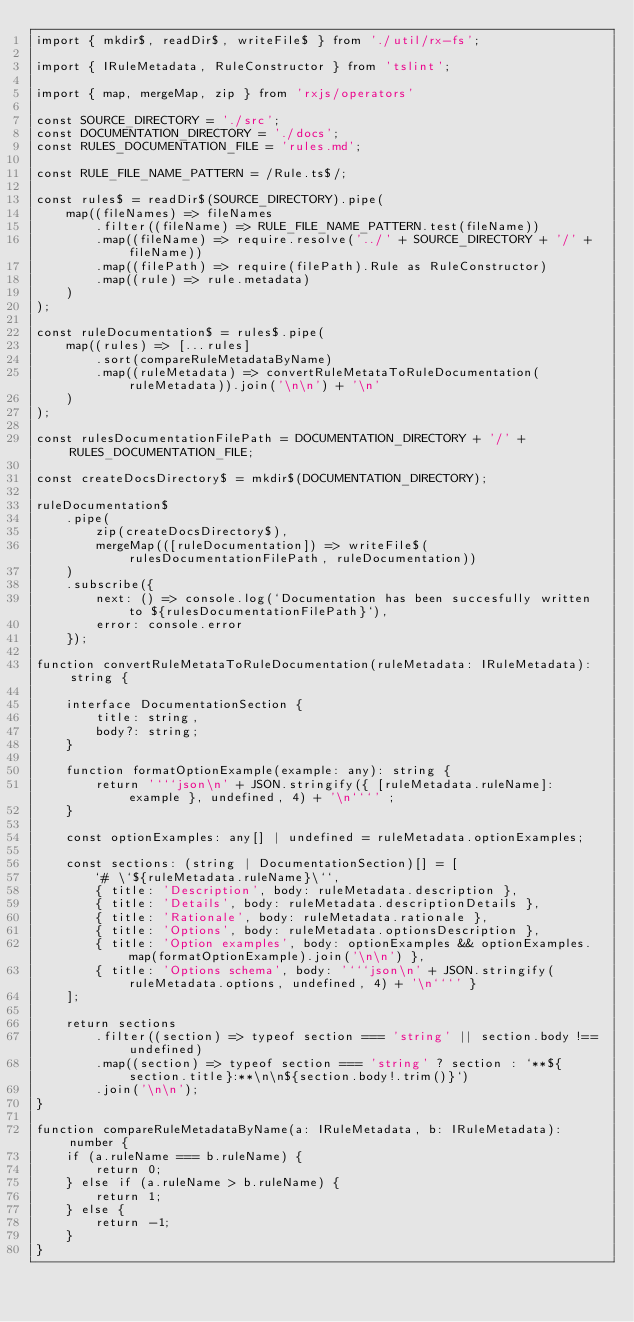Convert code to text. <code><loc_0><loc_0><loc_500><loc_500><_TypeScript_>import { mkdir$, readDir$, writeFile$ } from './util/rx-fs';

import { IRuleMetadata, RuleConstructor } from 'tslint';

import { map, mergeMap, zip } from 'rxjs/operators'

const SOURCE_DIRECTORY = './src';
const DOCUMENTATION_DIRECTORY = './docs';
const RULES_DOCUMENTATION_FILE = 'rules.md';

const RULE_FILE_NAME_PATTERN = /Rule.ts$/;

const rules$ = readDir$(SOURCE_DIRECTORY).pipe(
    map((fileNames) => fileNames
        .filter((fileName) => RULE_FILE_NAME_PATTERN.test(fileName))
        .map((fileName) => require.resolve('../' + SOURCE_DIRECTORY + '/' + fileName))
        .map((filePath) => require(filePath).Rule as RuleConstructor)
        .map((rule) => rule.metadata)
    )
);

const ruleDocumentation$ = rules$.pipe(
    map((rules) => [...rules]
        .sort(compareRuleMetadataByName)
        .map((ruleMetadata) => convertRuleMetataToRuleDocumentation(ruleMetadata)).join('\n\n') + '\n'
    )
);

const rulesDocumentationFilePath = DOCUMENTATION_DIRECTORY + '/' + RULES_DOCUMENTATION_FILE;

const createDocsDirectory$ = mkdir$(DOCUMENTATION_DIRECTORY);

ruleDocumentation$
    .pipe(
        zip(createDocsDirectory$),
        mergeMap(([ruleDocumentation]) => writeFile$(rulesDocumentationFilePath, ruleDocumentation))
    )
    .subscribe({
        next: () => console.log(`Documentation has been succesfully written to ${rulesDocumentationFilePath}`),
        error: console.error
    });

function convertRuleMetataToRuleDocumentation(ruleMetadata: IRuleMetadata): string {

    interface DocumentationSection {
        title: string,
        body?: string;
    }

    function formatOptionExample(example: any): string {
        return '```json\n' + JSON.stringify({ [ruleMetadata.ruleName]: example }, undefined, 4) + '\n```' ;
    }

    const optionExamples: any[] | undefined = ruleMetadata.optionExamples;

    const sections: (string | DocumentationSection)[] = [
        `# \`${ruleMetadata.ruleName}\``,
        { title: 'Description', body: ruleMetadata.description },
        { title: 'Details', body: ruleMetadata.descriptionDetails },
        { title: 'Rationale', body: ruleMetadata.rationale },
        { title: 'Options', body: ruleMetadata.optionsDescription },
        { title: 'Option examples', body: optionExamples && optionExamples.map(formatOptionExample).join('\n\n') },
        { title: 'Options schema', body: '```json\n' + JSON.stringify(ruleMetadata.options, undefined, 4) + '\n```' }
    ];

    return sections
        .filter((section) => typeof section === 'string' || section.body !== undefined)
        .map((section) => typeof section === 'string' ? section : `**${section.title}:**\n\n${section.body!.trim()}`)
        .join('\n\n');
}

function compareRuleMetadataByName(a: IRuleMetadata, b: IRuleMetadata): number {
    if (a.ruleName === b.ruleName) {
        return 0;
    } else if (a.ruleName > b.ruleName) {
        return 1;
    } else {
        return -1;
    }
}
</code> 